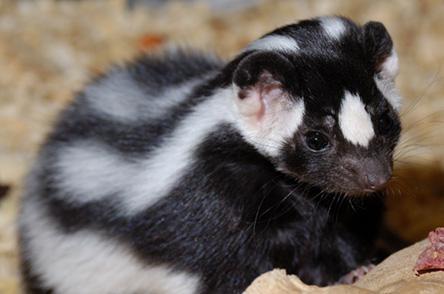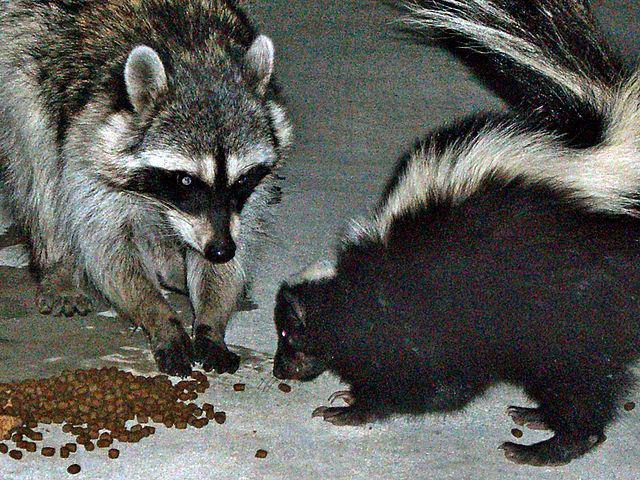The first image is the image on the left, the second image is the image on the right. Assess this claim about the two images: "There are just two skunks and no other animals.". Correct or not? Answer yes or no. No. The first image is the image on the left, the second image is the image on the right. Examine the images to the left and right. Is the description "Only two young skunks are shown and no other animals are visible." accurate? Answer yes or no. No. 